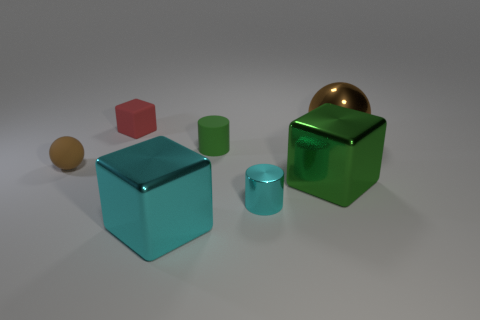Add 3 tiny brown balls. How many objects exist? 10 Subtract all cubes. How many objects are left? 4 Subtract 1 green cylinders. How many objects are left? 6 Subtract all cyan metal things. Subtract all green matte cylinders. How many objects are left? 4 Add 7 tiny brown balls. How many tiny brown balls are left? 8 Add 2 big purple shiny cylinders. How many big purple shiny cylinders exist? 2 